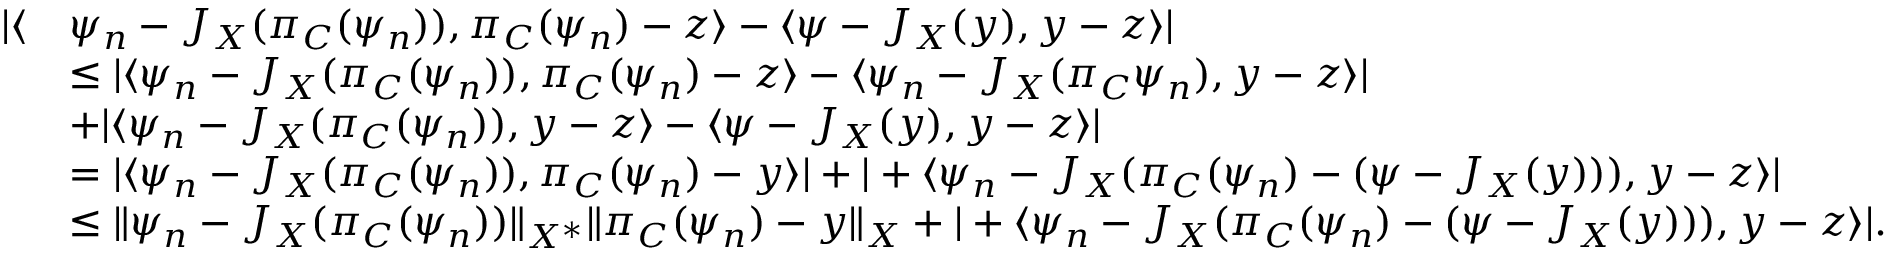<formula> <loc_0><loc_0><loc_500><loc_500>\begin{array} { r l } { | \langle } & { \psi _ { n } - J _ { X } ( \pi _ { C } ( \psi _ { n } ) ) , \pi _ { C } ( \psi _ { n } ) - z \rangle - \langle \psi - J _ { X } ( y ) , y - z \rangle | } \\ & { \leq | \langle \psi _ { n } - J _ { X } ( \pi _ { C } ( \psi _ { n } ) ) , \pi _ { C } ( \psi _ { n } ) - z \rangle - \langle \psi _ { n } - J _ { X } ( \pi _ { C } \psi _ { n } ) , y - z \rangle | } \\ & { + | \langle \psi _ { n } - J _ { X } ( \pi _ { C } ( \psi _ { n } ) ) , y - z \rangle - \langle \psi - J _ { X } ( y ) , y - z \rangle | } \\ & { = | \langle \psi _ { n } - J _ { X } ( \pi _ { C } ( \psi _ { n } ) ) , \pi _ { C } ( \psi _ { n } ) - y \rangle | + | + \langle \psi _ { n } - J _ { X } ( \pi _ { C } ( \psi _ { n } ) - ( \psi - J _ { X } ( y ) ) ) , y - z \rangle | } \\ & { \leq \| \psi _ { n } - J _ { X } ( \pi _ { C } ( \psi _ { n } ) ) \| _ { X ^ { * } } \| \pi _ { C } ( \psi _ { n } ) - y \| _ { X } + | + \langle \psi _ { n } - J _ { X } ( \pi _ { C } ( \psi _ { n } ) - ( \psi - J _ { X } ( y ) ) ) , y - z \rangle | . } \end{array}</formula> 